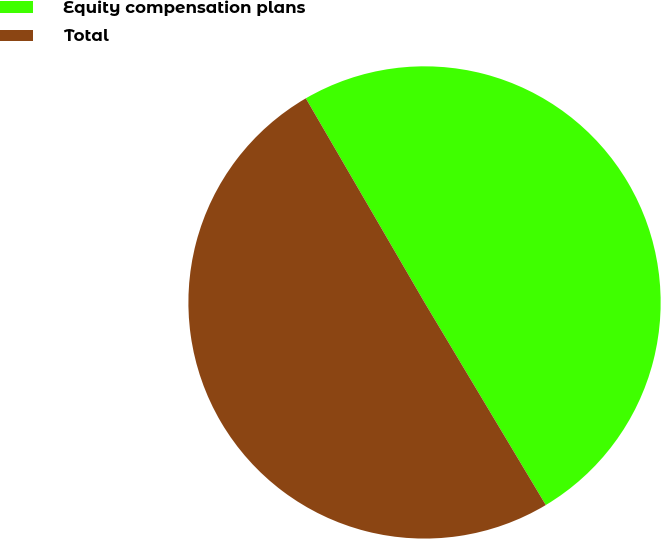Convert chart. <chart><loc_0><loc_0><loc_500><loc_500><pie_chart><fcel>Equity compensation plans<fcel>Total<nl><fcel>49.8%<fcel>50.2%<nl></chart> 